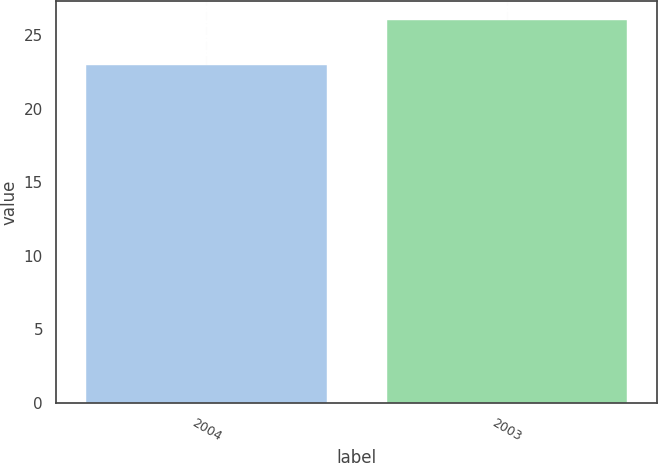Convert chart to OTSL. <chart><loc_0><loc_0><loc_500><loc_500><bar_chart><fcel>2004<fcel>2003<nl><fcel>23<fcel>26<nl></chart> 